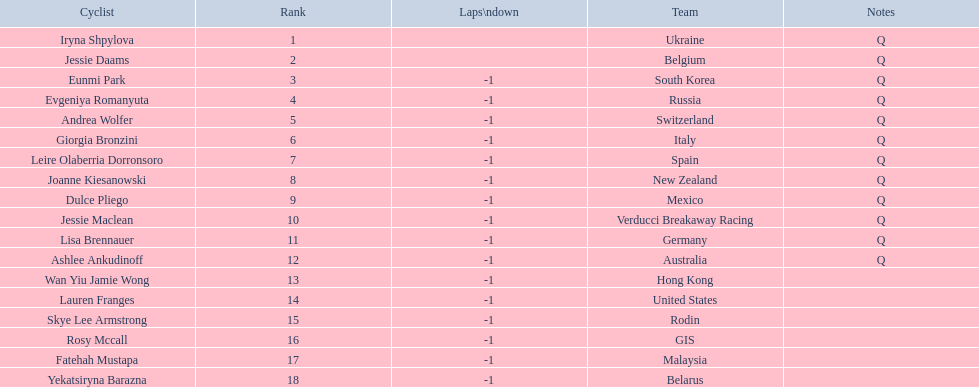Who was the first competitor to finish the race a lap behind? Eunmi Park. 